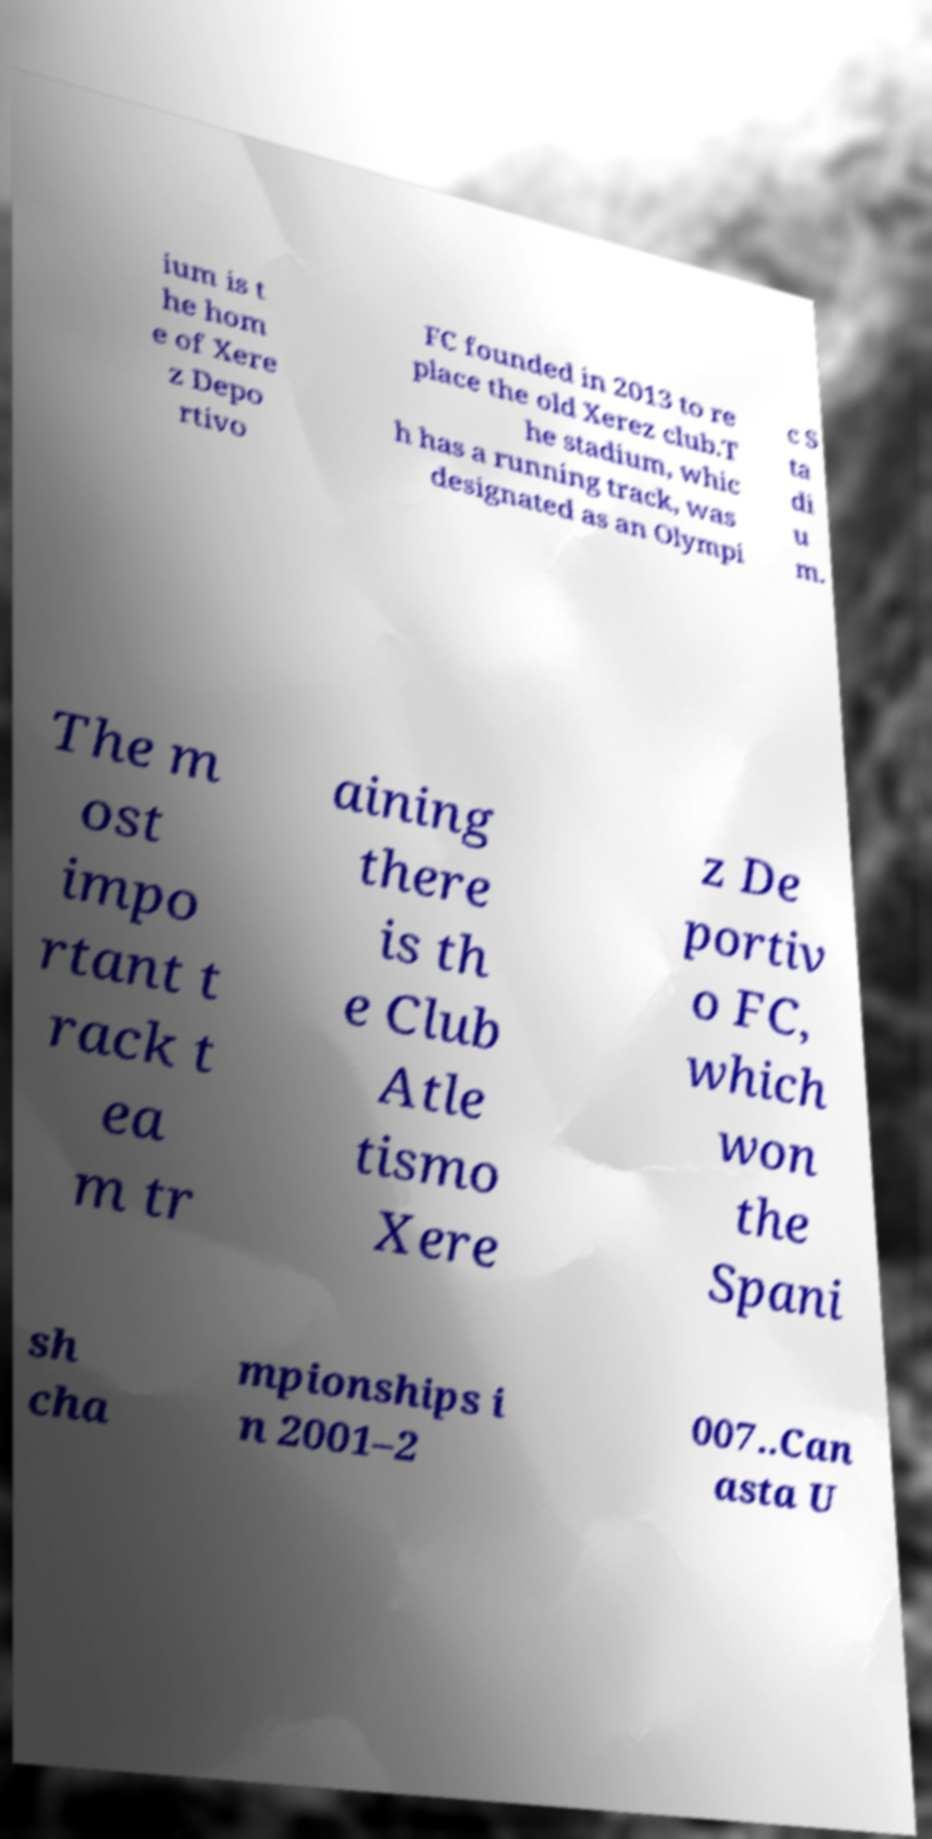For documentation purposes, I need the text within this image transcribed. Could you provide that? ium is t he hom e of Xere z Depo rtivo FC founded in 2013 to re place the old Xerez club.T he stadium, whic h has a running track, was designated as an Olympi c S ta di u m. The m ost impo rtant t rack t ea m tr aining there is th e Club Atle tismo Xere z De portiv o FC, which won the Spani sh cha mpionships i n 2001–2 007..Can asta U 